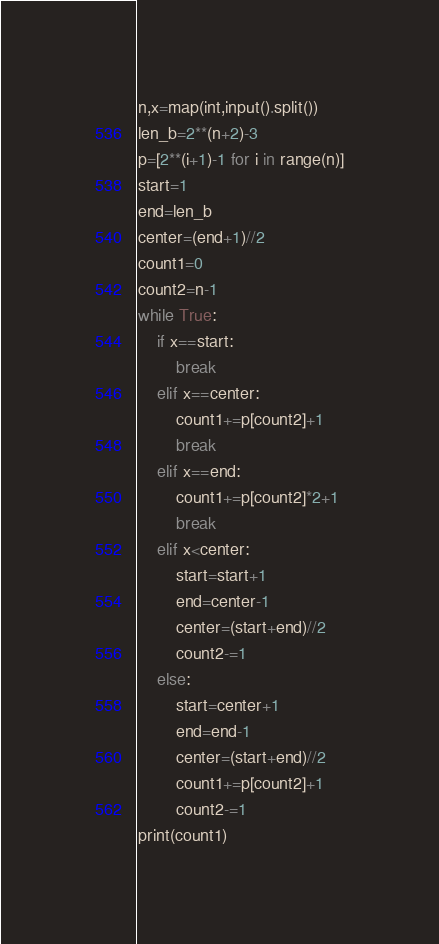<code> <loc_0><loc_0><loc_500><loc_500><_Python_>n,x=map(int,input().split())
len_b=2**(n+2)-3
p=[2**(i+1)-1 for i in range(n)]
start=1
end=len_b
center=(end+1)//2
count1=0
count2=n-1
while True:
    if x==start:
        break
    elif x==center:
        count1+=p[count2]+1
        break
    elif x==end:
        count1+=p[count2]*2+1
        break
    elif x<center:
        start=start+1
        end=center-1
        center=(start+end)//2
        count2-=1
    else:
        start=center+1
        end=end-1
        center=(start+end)//2
        count1+=p[count2]+1
        count2-=1
print(count1)</code> 